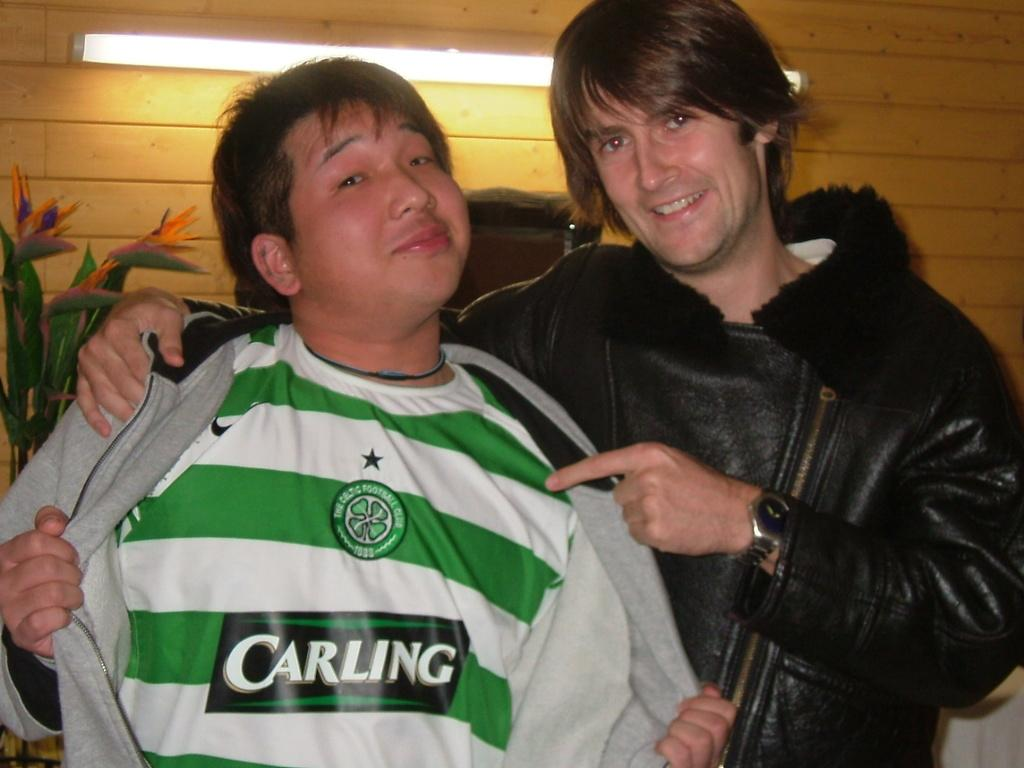How many people are in the image? There are two men standing in the image. What can be seen on the left side of the image? There is a plant towards the left side of the image. What is the source of illumination in the image? There is a light in the image. What is visible in the background of the image? There is a wall in the background of the image. How many tomatoes are hanging from the wall in the image? There are no tomatoes visible in the image; only a plant and a wall are present. What type of hydrant can be seen in the image? There is no hydrant present in the image. 